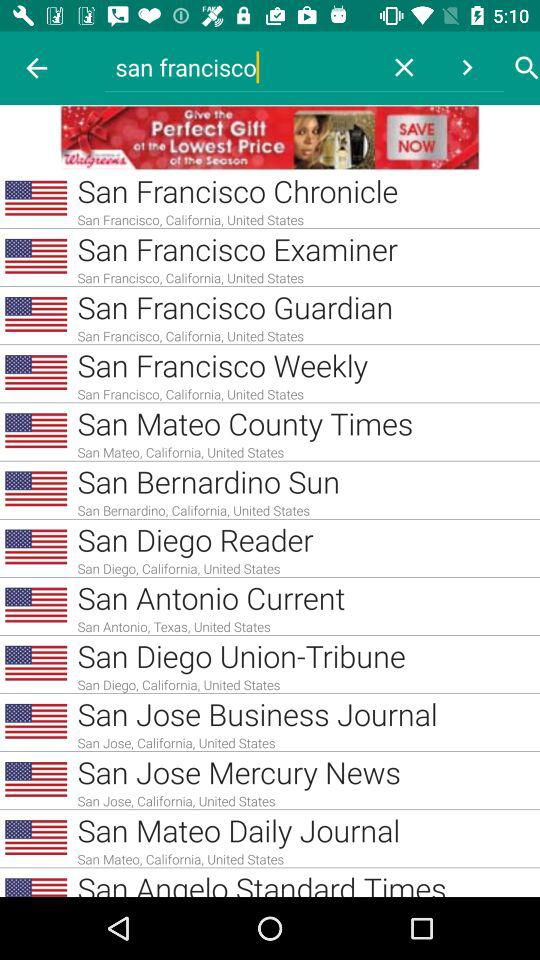What location is the person searching for? The person is searching for San Francisco. 